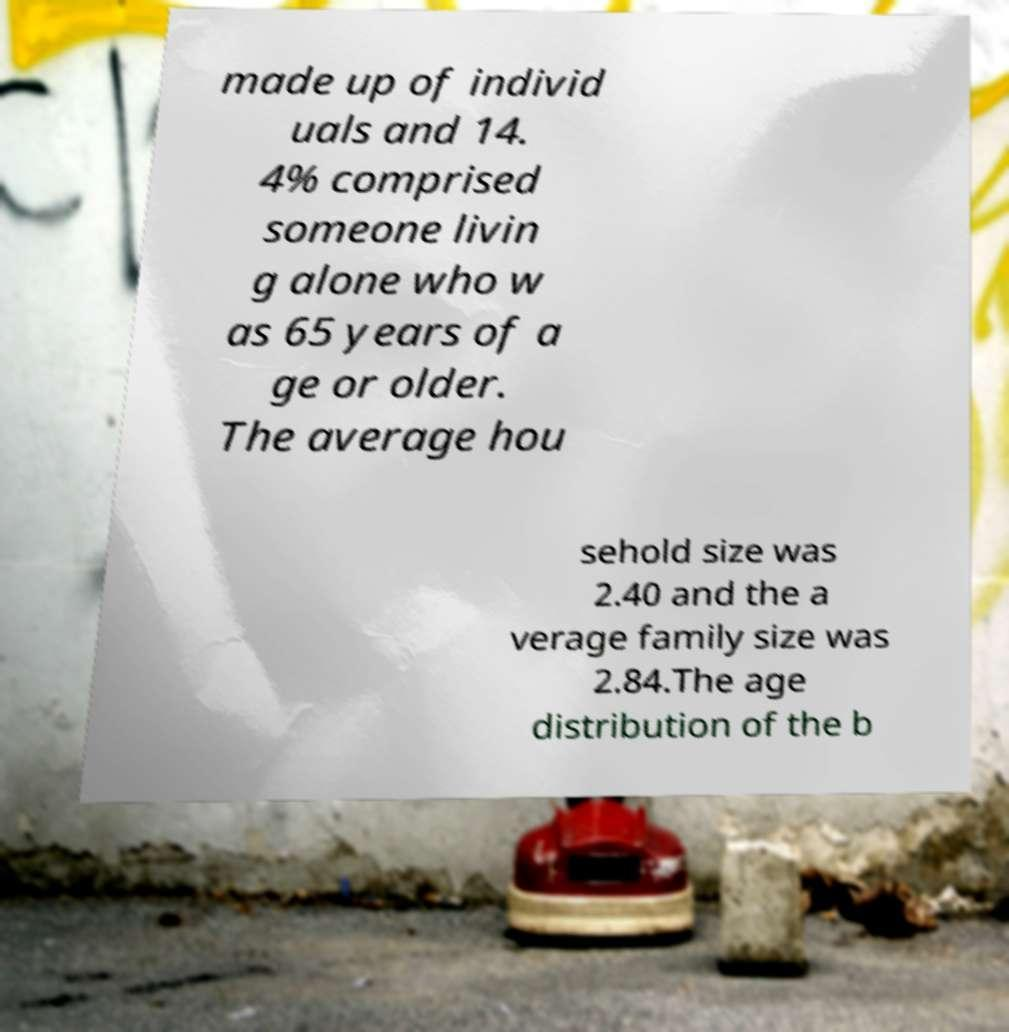I need the written content from this picture converted into text. Can you do that? made up of individ uals and 14. 4% comprised someone livin g alone who w as 65 years of a ge or older. The average hou sehold size was 2.40 and the a verage family size was 2.84.The age distribution of the b 